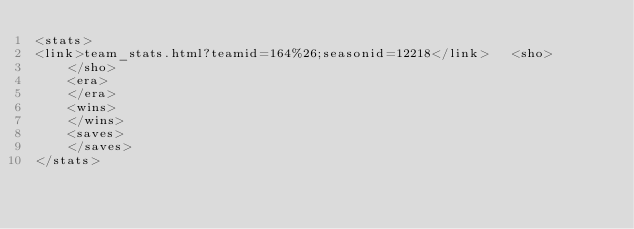Convert code to text. <code><loc_0><loc_0><loc_500><loc_500><_XML_><stats>
<link>team_stats.html?teamid=164%26;seasonid=12218</link>	<sho>
	</sho>
	<era>
	</era>
	<wins>
	</wins>
	<saves>
	</saves>
</stats>
</code> 